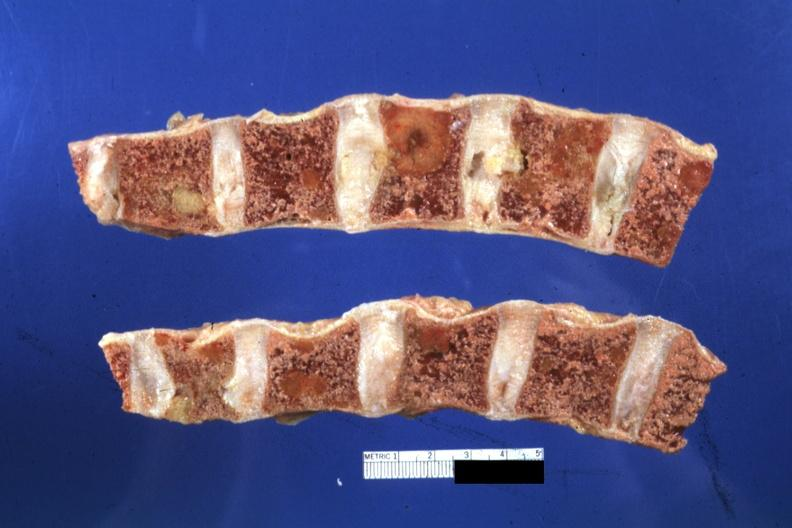what is off?
Answer the question using a single word or phrase. Color 